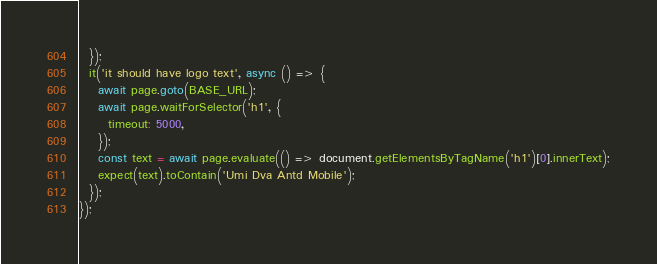<code> <loc_0><loc_0><loc_500><loc_500><_JavaScript_>  });
  it('it should have logo text', async () => {
    await page.goto(BASE_URL);
    await page.waitForSelector('h1', {
      timeout: 5000,
    });
    const text = await page.evaluate(() => document.getElementsByTagName('h1')[0].innerText);
    expect(text).toContain('Umi Dva Antd Mobile');
  });
});
</code> 